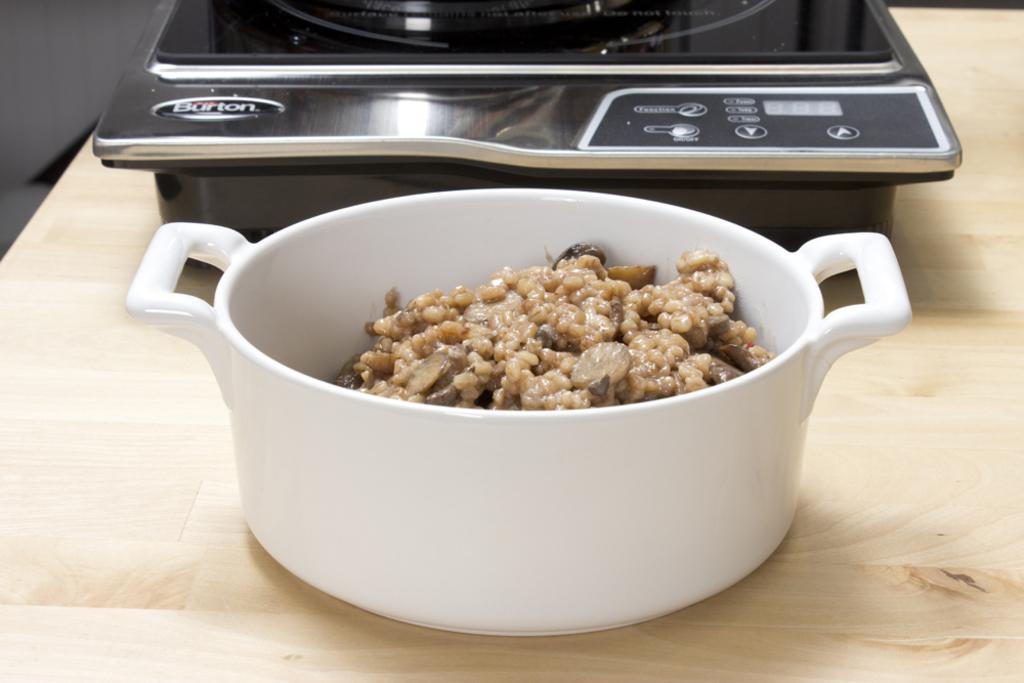<image>
Relay a brief, clear account of the picture shown. the name Burton is on the black item on the table 